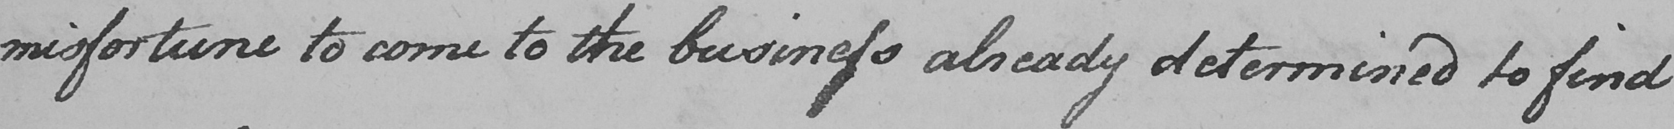Transcribe the text shown in this historical manuscript line. misfortune to come to the business already determined to find  _ 